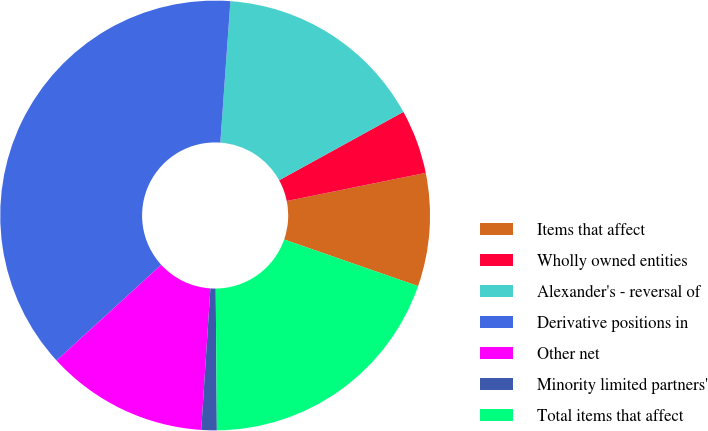Convert chart to OTSL. <chart><loc_0><loc_0><loc_500><loc_500><pie_chart><fcel>Items that affect<fcel>Wholly owned entities<fcel>Alexander's - reversal of<fcel>Derivative positions in<fcel>Other net<fcel>Minority limited partners'<fcel>Total items that affect<nl><fcel>8.51%<fcel>4.83%<fcel>15.86%<fcel>37.92%<fcel>12.18%<fcel>1.16%<fcel>19.54%<nl></chart> 